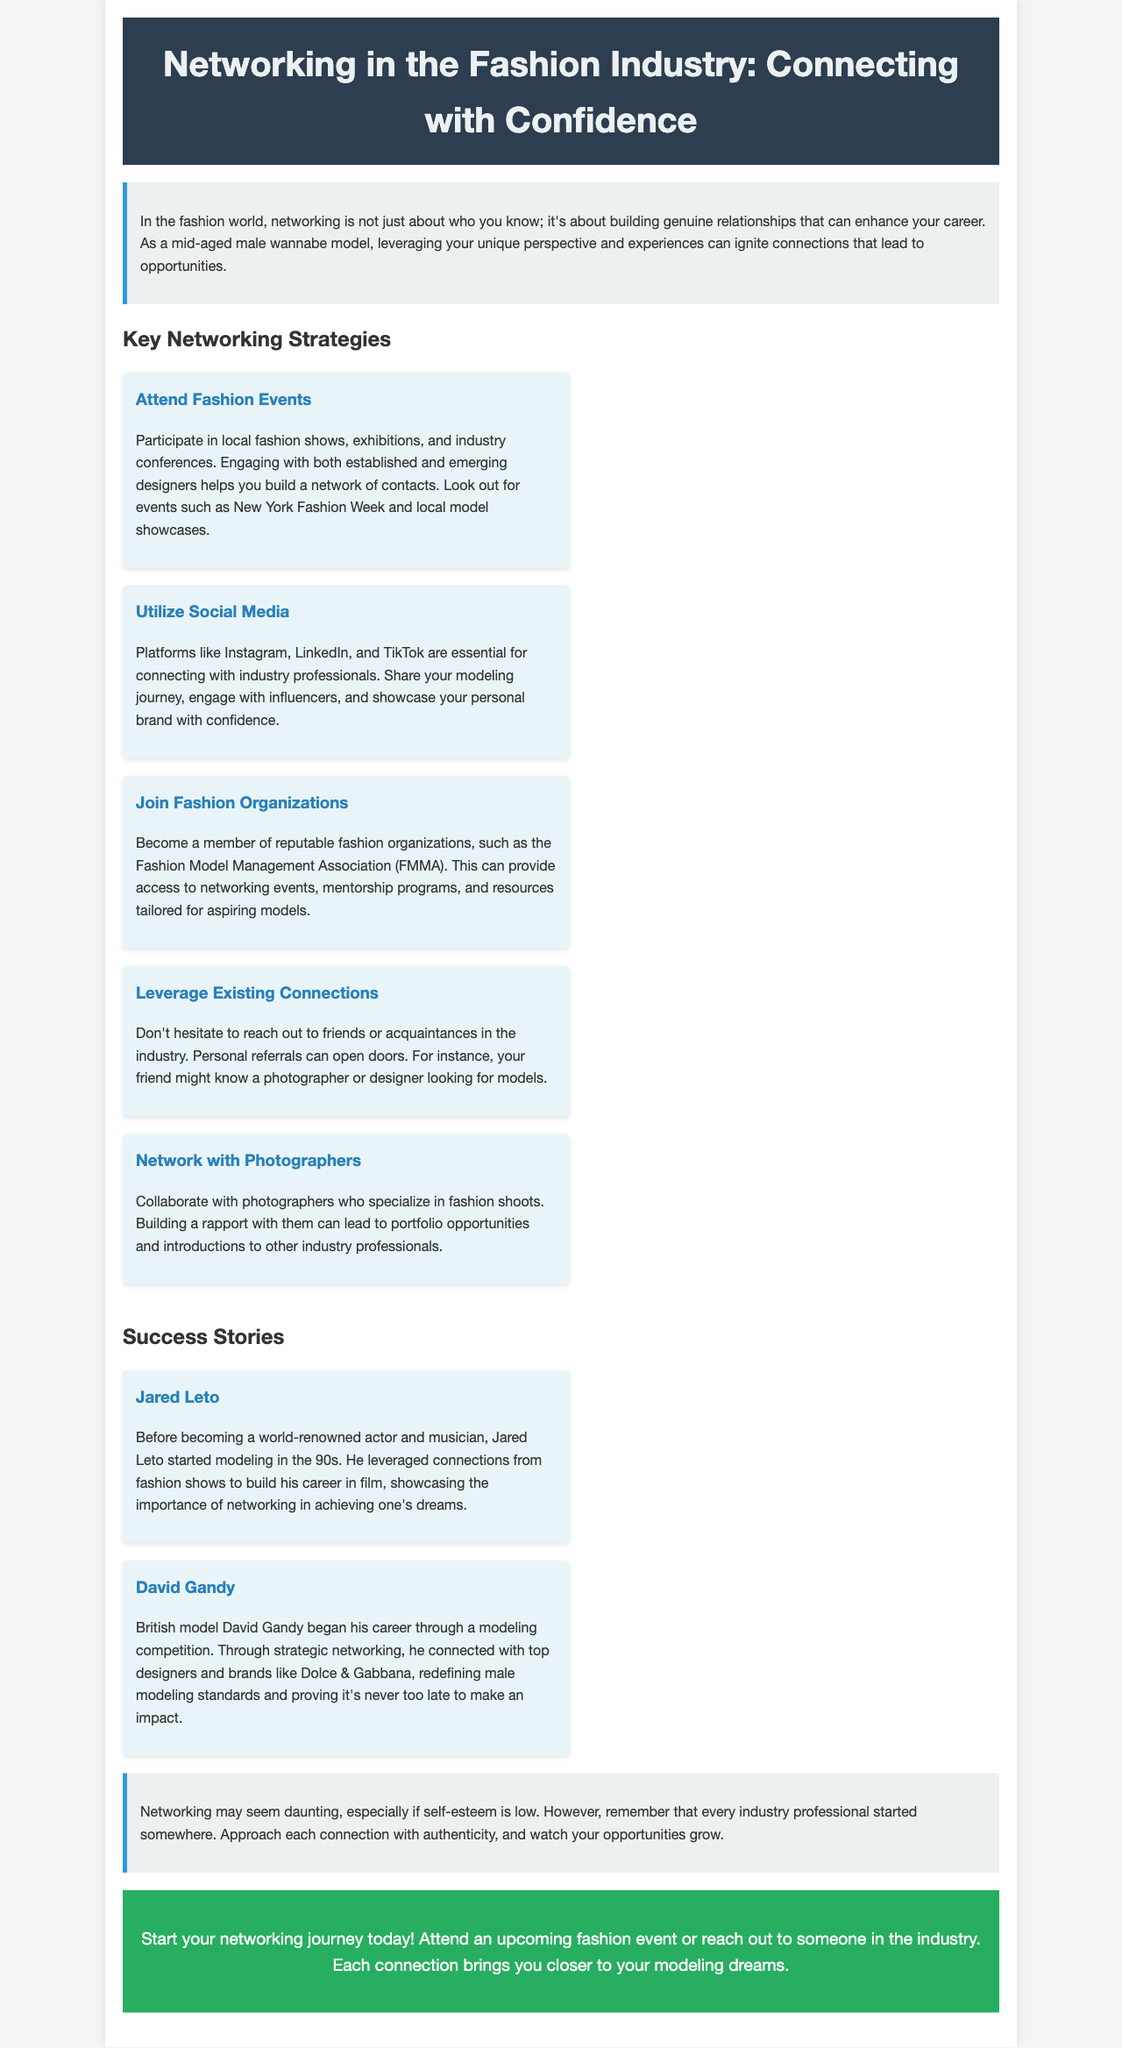What is the title of the brochure? The title of the brochure is stated in the header section of the document.
Answer: Networking in the Fashion Industry: Connecting with Confidence How many key networking strategies are listed? The document specifies the number of strategies in the section dedicated to Networking Strategies.
Answer: Five What are platforms mentioned for utilizing social media? The document lists specific platforms that are essential for connecting with industry professionals.
Answer: Instagram, LinkedIn, TikTok Who is the British model mentioned as a success story? The success story section highlights notable individuals, including this model.
Answer: David Gandy What event is suggested for attending to build connections? Attending events is recommended in the strategies section, specifying a major event pertinent to the fashion industry.
Answer: New York Fashion Week What is a suggestion for leveraging existing connections? The document advises reaching out to personal contacts for potential opportunities in the industry.
Answer: Personal referrals What does Jared Leto's success story illustrate? The information given in his story emphasizes a particular theme related to networking and career growth.
Answer: Importance of networking What attitude is encouraged towards networking, despite low self-esteem? The conclusion reassures readers about their approach to networking in the fashion industry.
Answer: Authenticity 